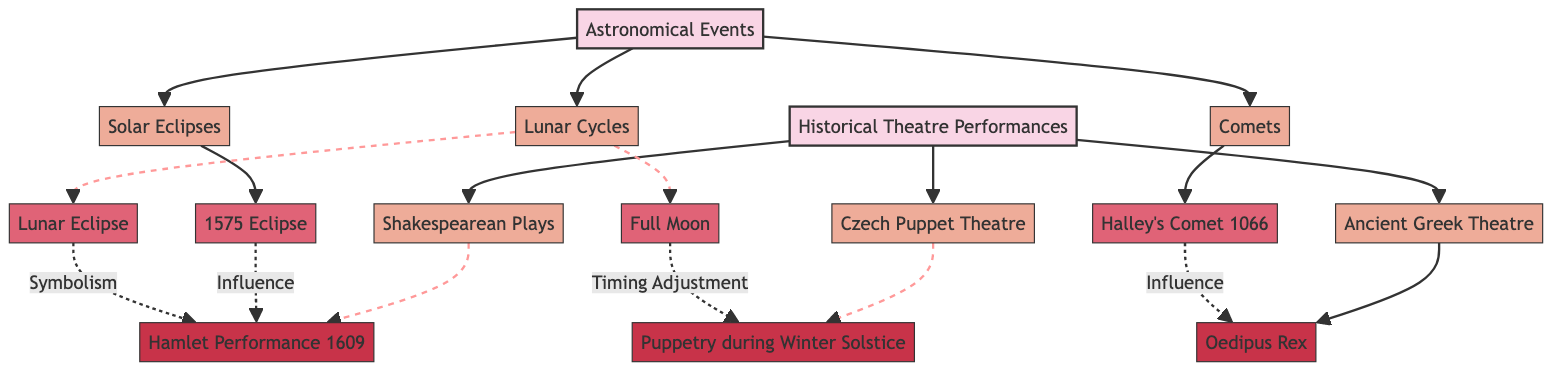What are the three categories in the diagram? The diagram consists of two main categories: "Astronomical Events" and "Historical Theatre Performances." These categories are top-level nodes in the flowchart.
Answer: Astronomical Events, Historical Theatre Performances Which event is linked to "Hamlet Performance 1609"? "Hamlet Performance 1609" is connected to "1575 Eclipse," indicated by a dashed line labeled "Influence." This shows that the eclipse had an impact on the performance.
Answer: 1575 Eclipse How many subcategories are under "Historical Theatre Performances"? There are three subcategories under "Historical Theatre Performances": "Shakespearean Plays," "Czech Puppet Theatre," and "Ancient Greek Theatre." Each of these is a child node branching from the main category.
Answer: 3 What effect did "Lunar Eclipse" have on "Hamlet Performance 1609"? The "Lunar Eclipse" is associated with "Hamlet Performance 1609" in the diagram, where it is labeled as having an influence, specifically indicated as "Symbolism." This suggests that it carried symbolic meaning for the performance.
Answer: Symbolism Which astronomical event influenced the "Puppetry during Winter Solstice"? The diagram notes that the "Full Moon" influenced the "Puppetry during Winter Solstice," indicated by the connection labeled "Timing Adjustment." This implies that the timing for the puppet performance was adjusted based on the full moon's occurrence.
Answer: Timing Adjustment What is the connection between "Halley's Comet 1066" and "Oedipus Rex"? "Oedipus Rex" is influenced by "Halley's Comet 1066," as shown by the dashed line labeled "Influence" leading from the comet to the play. This connection suggests that the comet had an impact on the themes or timing of the performance.
Answer: Influence How many events are listed under "Astronomical Events"? The diagram lists four events under "Astronomical Events": "1575 Eclipse," "Halley's Comet 1066," "Full Moon," and "Lunar Eclipse." These events are connected to their respective subcategories.
Answer: 4 What type of performance is associated with "Winter Solstice"? The associated performance for "Winter Solstice" is "Puppetry during Winter Solstice," which is a subcategory of "Czech Puppet Theatre." This indicates a specific cultural practice related to the solstice event.
Answer: Puppetry during Winter Solstice 